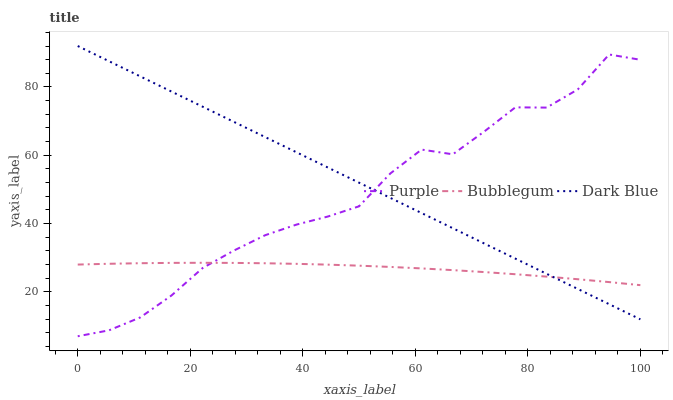Does Bubblegum have the minimum area under the curve?
Answer yes or no. Yes. Does Dark Blue have the maximum area under the curve?
Answer yes or no. Yes. Does Dark Blue have the minimum area under the curve?
Answer yes or no. No. Does Bubblegum have the maximum area under the curve?
Answer yes or no. No. Is Dark Blue the smoothest?
Answer yes or no. Yes. Is Purple the roughest?
Answer yes or no. Yes. Is Bubblegum the smoothest?
Answer yes or no. No. Is Bubblegum the roughest?
Answer yes or no. No. Does Purple have the lowest value?
Answer yes or no. Yes. Does Dark Blue have the lowest value?
Answer yes or no. No. Does Dark Blue have the highest value?
Answer yes or no. Yes. Does Bubblegum have the highest value?
Answer yes or no. No. Does Bubblegum intersect Purple?
Answer yes or no. Yes. Is Bubblegum less than Purple?
Answer yes or no. No. Is Bubblegum greater than Purple?
Answer yes or no. No. 